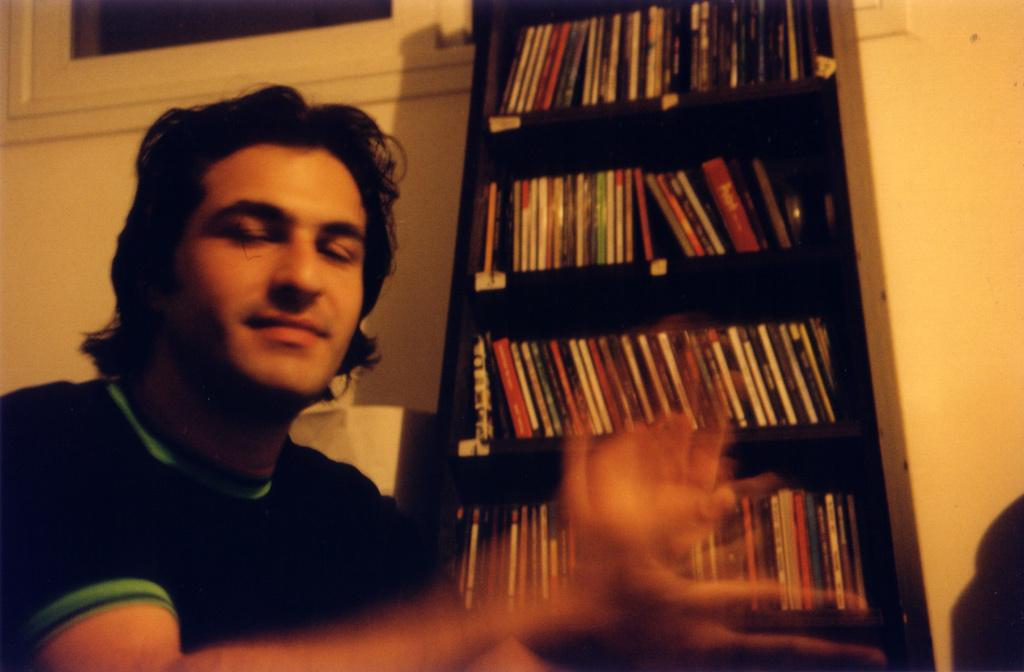What is the main subject of the image? There is a person in the image. What is the person wearing? The person is wearing a black t-shirt. Where is the person sitting in relation to other objects in the image? The person is sitting near a wall. What is located near the wall? The wall is near a cupboard. Can you describe the cupboard? The cupboard has shelves. What is on the shelves? There are books arranged on the shelves. How many horses are visible in the image? There are no horses present in the image. Is there a woman in the image? The provided facts do not mention a woman, only a person. 